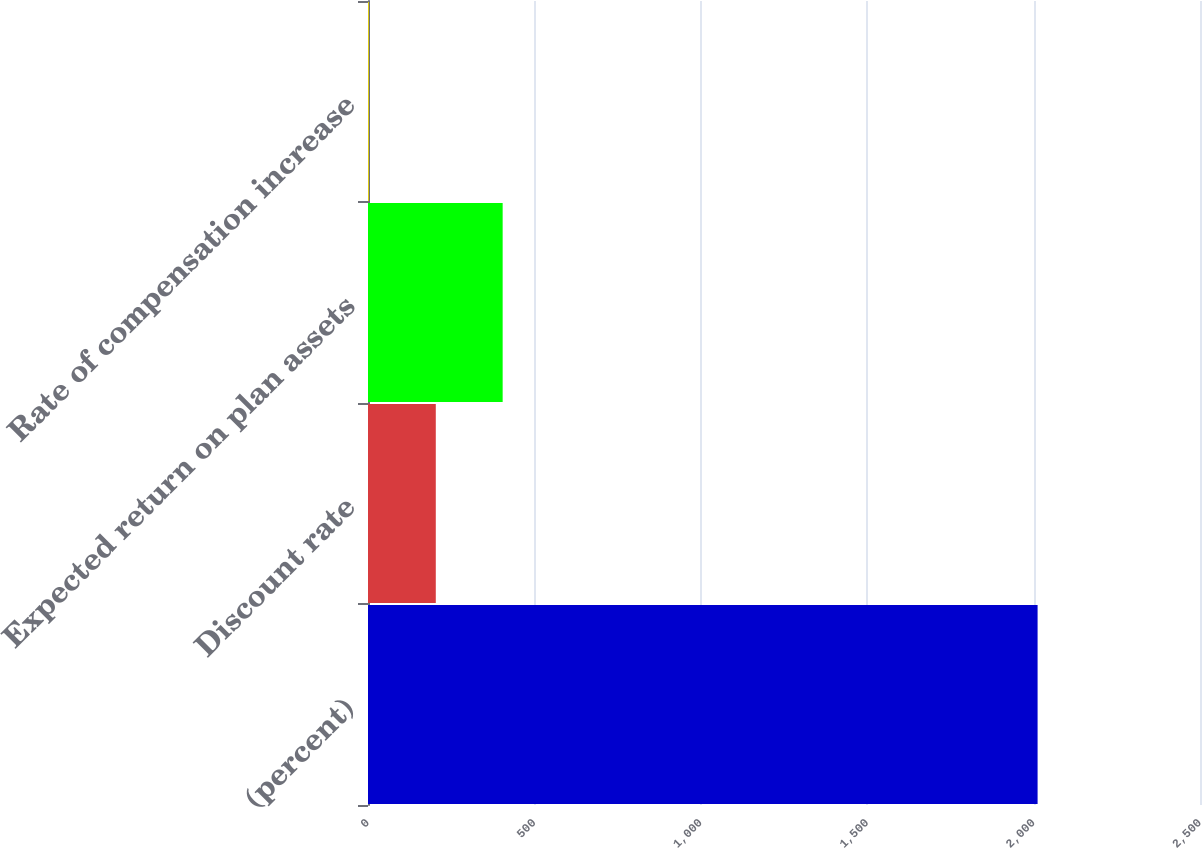Convert chart. <chart><loc_0><loc_0><loc_500><loc_500><bar_chart><fcel>(percent)<fcel>Discount rate<fcel>Expected return on plan assets<fcel>Rate of compensation increase<nl><fcel>2012<fcel>203.7<fcel>404.62<fcel>2.78<nl></chart> 